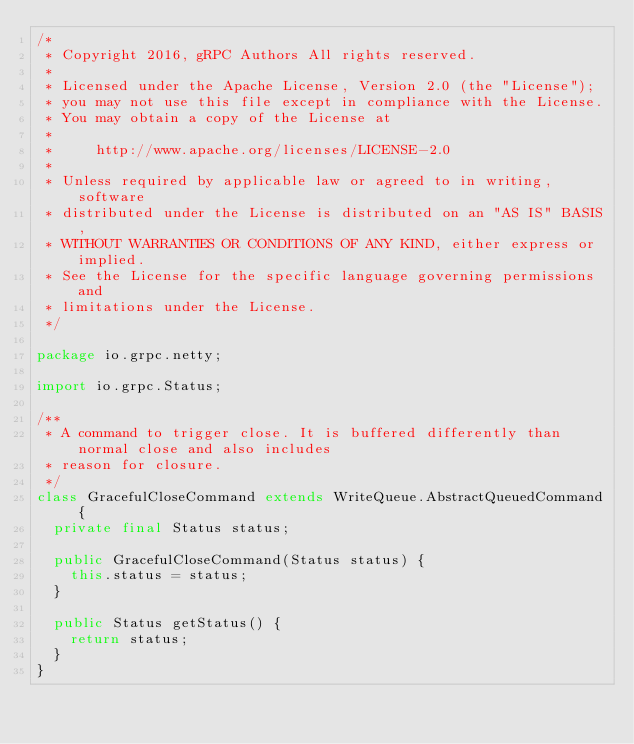<code> <loc_0><loc_0><loc_500><loc_500><_Java_>/*
 * Copyright 2016, gRPC Authors All rights reserved.
 *
 * Licensed under the Apache License, Version 2.0 (the "License");
 * you may not use this file except in compliance with the License.
 * You may obtain a copy of the License at
 *
 *     http://www.apache.org/licenses/LICENSE-2.0
 *
 * Unless required by applicable law or agreed to in writing, software
 * distributed under the License is distributed on an "AS IS" BASIS,
 * WITHOUT WARRANTIES OR CONDITIONS OF ANY KIND, either express or implied.
 * See the License for the specific language governing permissions and
 * limitations under the License.
 */

package io.grpc.netty;

import io.grpc.Status;

/**
 * A command to trigger close. It is buffered differently than normal close and also includes
 * reason for closure.
 */
class GracefulCloseCommand extends WriteQueue.AbstractQueuedCommand {
  private final Status status;

  public GracefulCloseCommand(Status status) {
    this.status = status;
  }

  public Status getStatus() {
    return status;
  }
}
</code> 